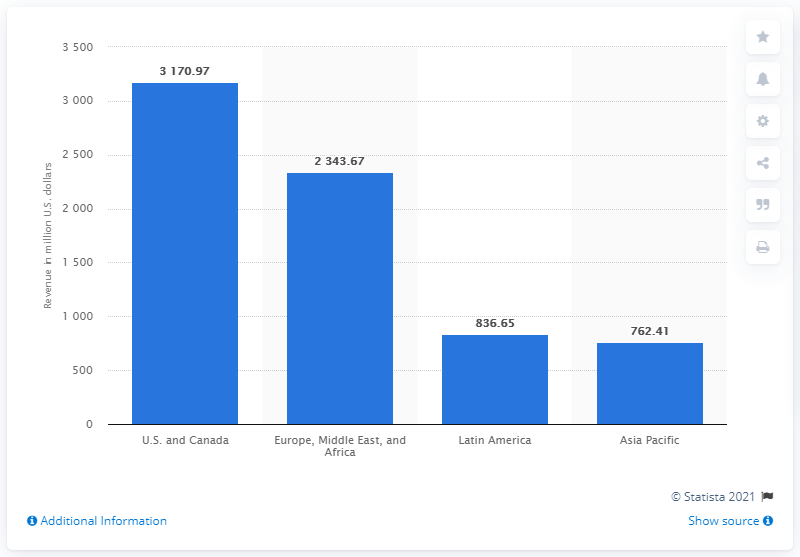Outline some significant characteristics in this image. In the first quarter of 2021, Netflix's revenue from Latin America was 836.65 million. 